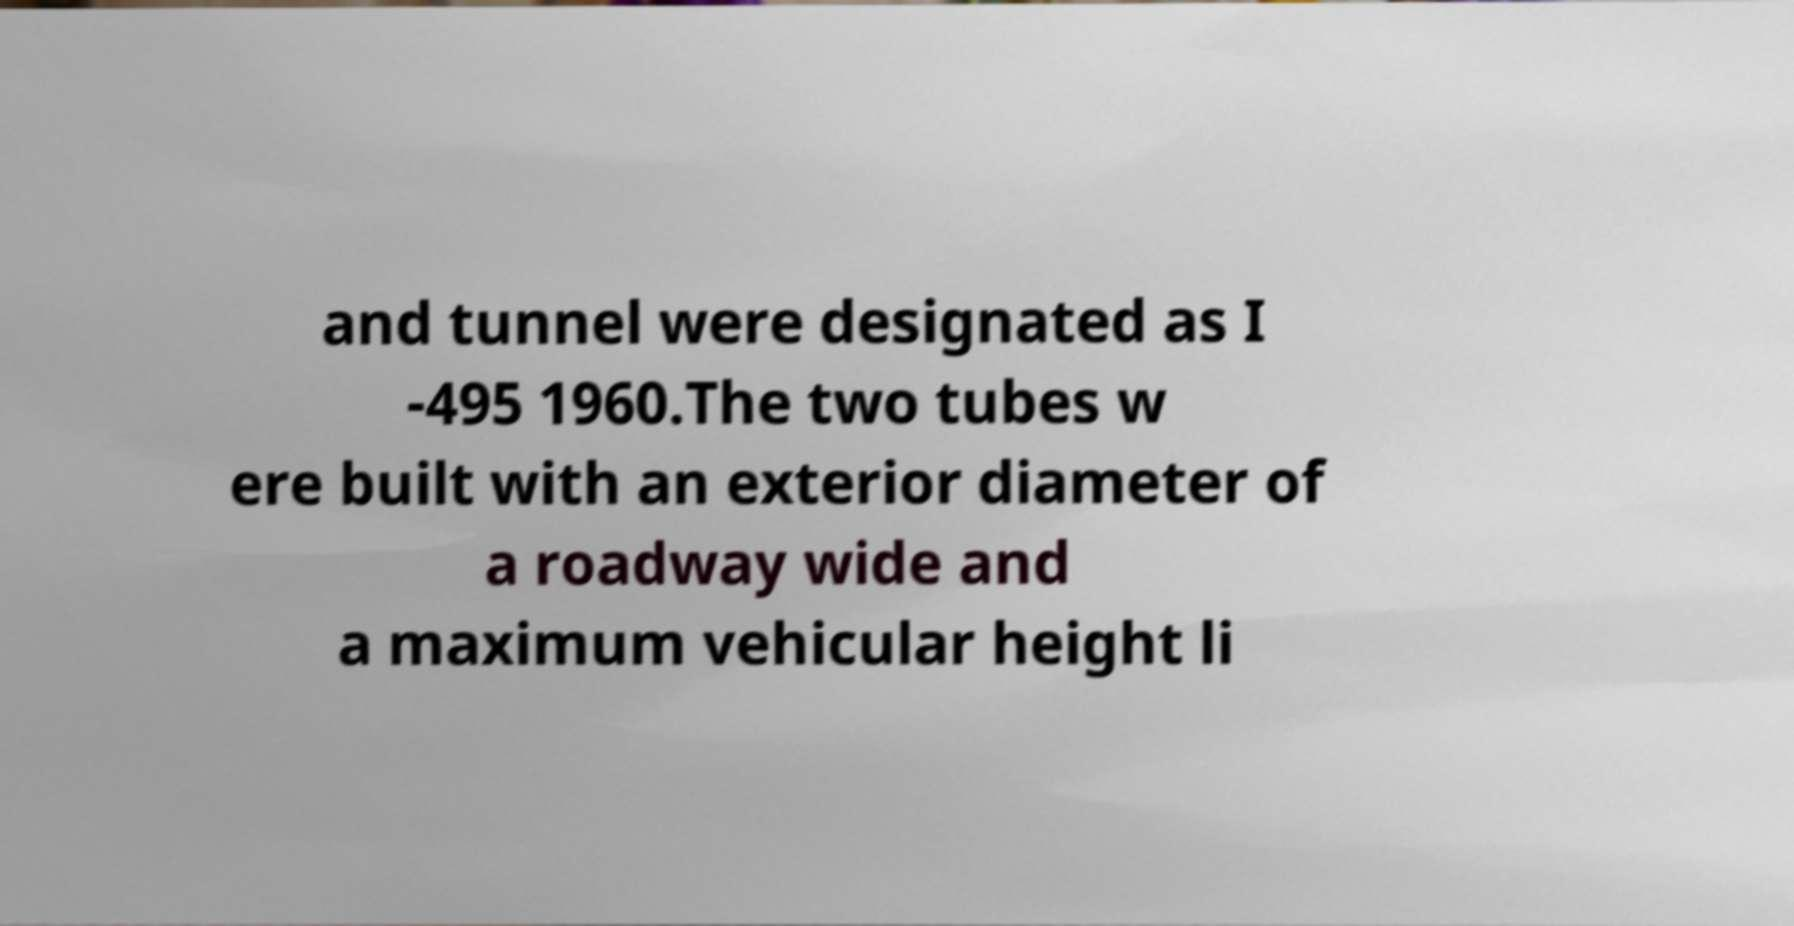I need the written content from this picture converted into text. Can you do that? and tunnel were designated as I -495 1960.The two tubes w ere built with an exterior diameter of a roadway wide and a maximum vehicular height li 